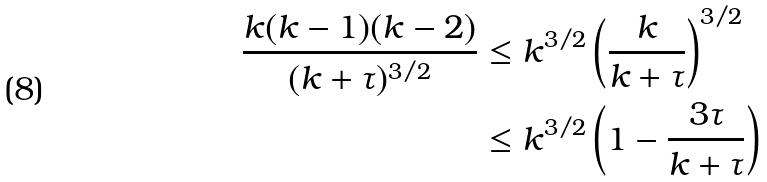Convert formula to latex. <formula><loc_0><loc_0><loc_500><loc_500>\frac { k ( k - 1 ) ( k - 2 ) } { ( k + \tau ) ^ { 3 / 2 } } & \leq k ^ { 3 / 2 } \left ( \frac { k } { k + \tau } \right ) ^ { 3 / 2 } \\ & \leq k ^ { 3 / 2 } \left ( 1 - \frac { 3 \tau } { k + \tau } \right )</formula> 